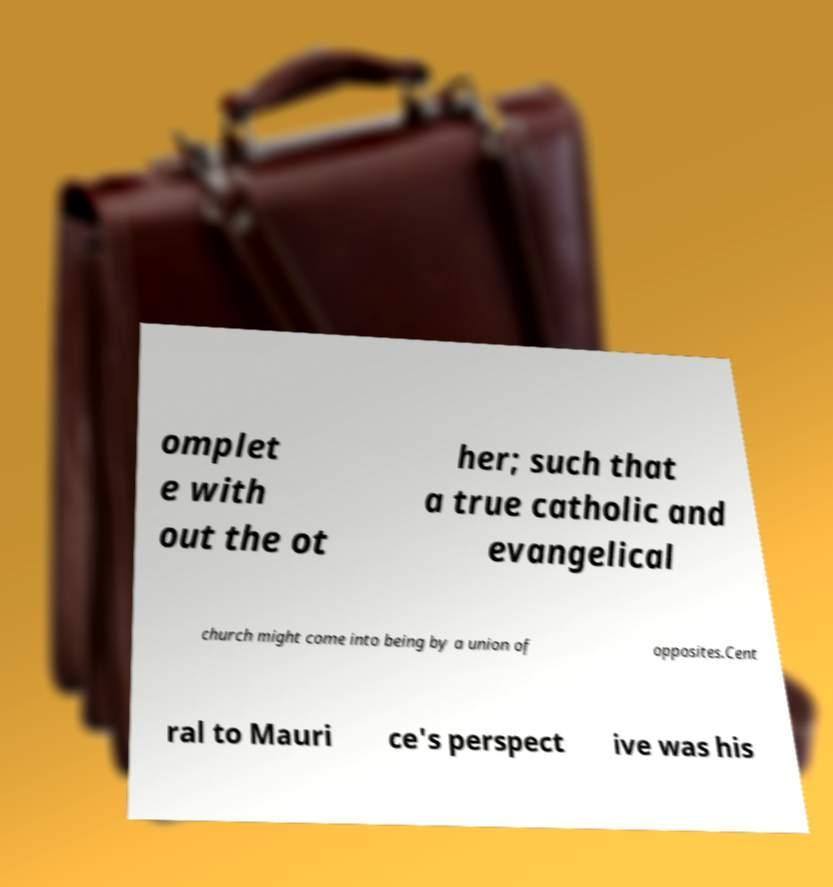I need the written content from this picture converted into text. Can you do that? omplet e with out the ot her; such that a true catholic and evangelical church might come into being by a union of opposites.Cent ral to Mauri ce's perspect ive was his 